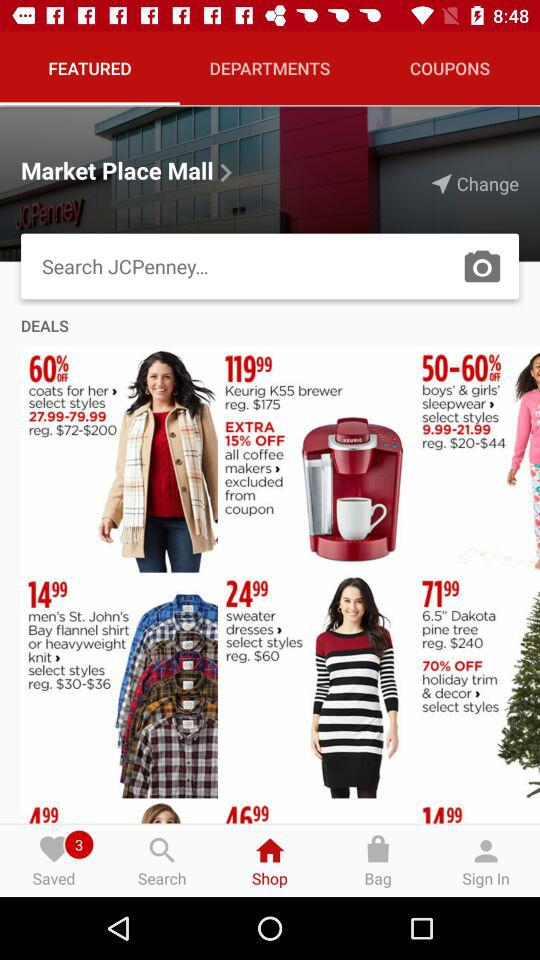Which tab am I now on? You are on the "Shop" and "FEATURED" tabs. 